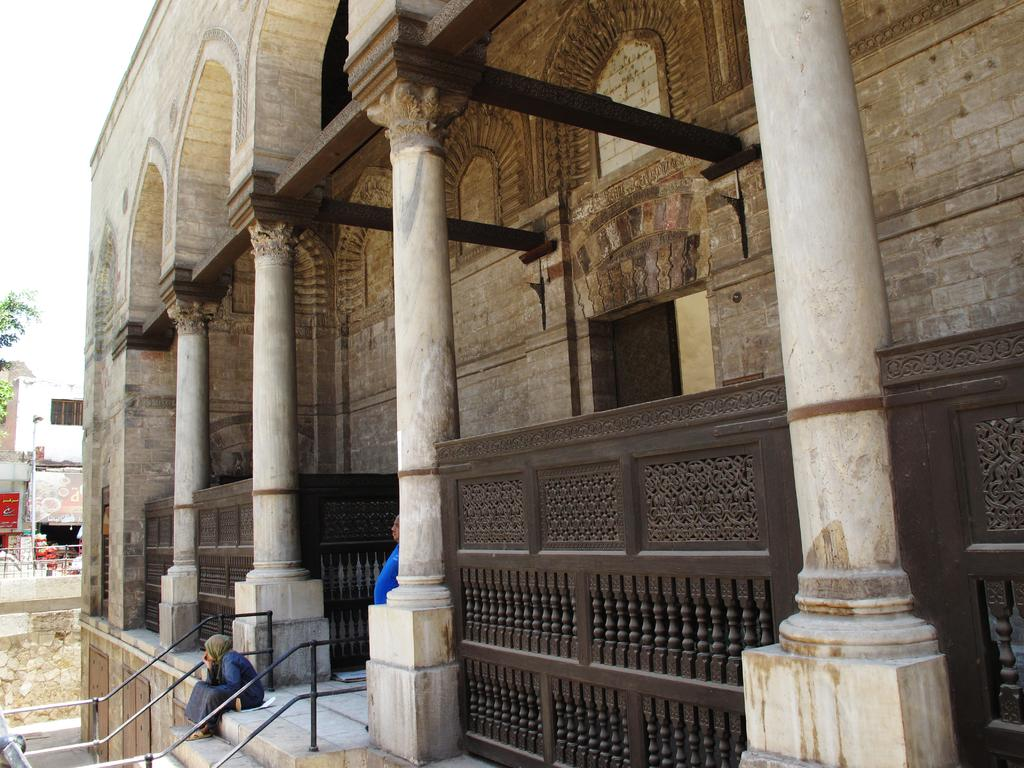What type of structures can be seen in the image? There are buildings in the image. Can you describe the human in the image? There is a human standing in the image. What is the woman in the image doing? The woman is seated on the stairs in the image. What type of vegetation is visible in the image? There is a tree visible in the image. How would you describe the weather in the image? The sky is cloudy in the image. What type of alarm is the tree in the image? There is no alarm present in the image; it features a tree and other subjects. Can you provide an example of a woman sitting on stairs in the image? There is already a description of the woman seated on the stairs in the image, so no further example is needed. 